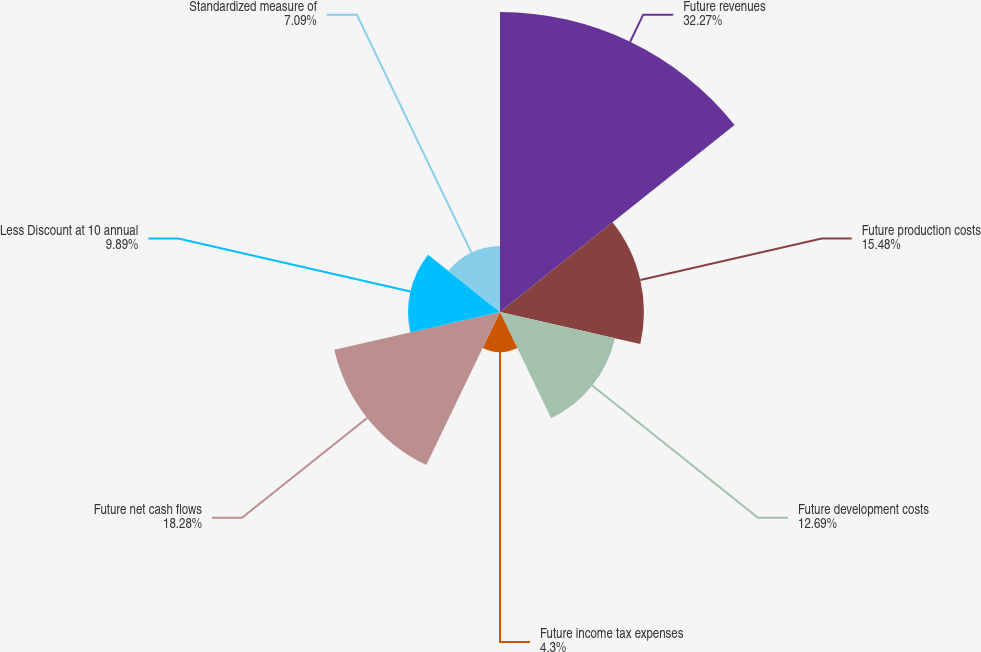Convert chart to OTSL. <chart><loc_0><loc_0><loc_500><loc_500><pie_chart><fcel>Future revenues<fcel>Future production costs<fcel>Future development costs<fcel>Future income tax expenses<fcel>Future net cash flows<fcel>Less Discount at 10 annual<fcel>Standardized measure of<nl><fcel>32.27%<fcel>15.48%<fcel>12.69%<fcel>4.3%<fcel>18.28%<fcel>9.89%<fcel>7.09%<nl></chart> 